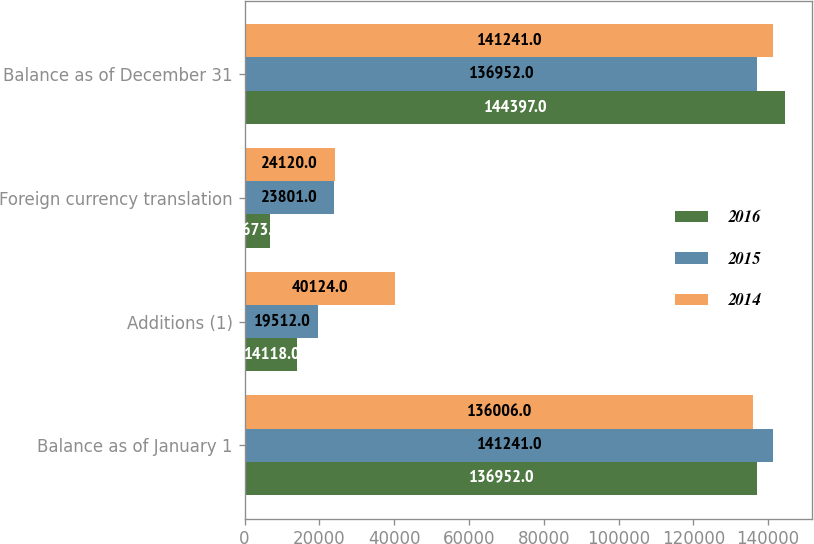Convert chart. <chart><loc_0><loc_0><loc_500><loc_500><stacked_bar_chart><ecel><fcel>Balance as of January 1<fcel>Additions (1)<fcel>Foreign currency translation<fcel>Balance as of December 31<nl><fcel>2016<fcel>136952<fcel>14118<fcel>6673<fcel>144397<nl><fcel>2015<fcel>141241<fcel>19512<fcel>23801<fcel>136952<nl><fcel>2014<fcel>136006<fcel>40124<fcel>24120<fcel>141241<nl></chart> 